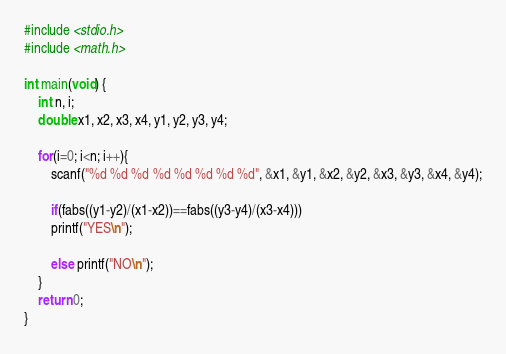<code> <loc_0><loc_0><loc_500><loc_500><_C_>#include <stdio.h>
#include <math.h>

int main(void) {
	int n, i;
	double x1, x2, x3, x4, y1, y2, y3, y4;
	
	for(i=0; i<n; i++){
		scanf("%d %d %d %d %d %d %d %d", &x1, &y1, &x2, &y2, &x3, &y3, &x4, &y4);
		
		if(fabs((y1-y2)/(x1-x2))==fabs((y3-y4)/(x3-x4)))
		printf("YES\n");
		
		else printf("NO\n");
	}
	return 0;
}</code> 